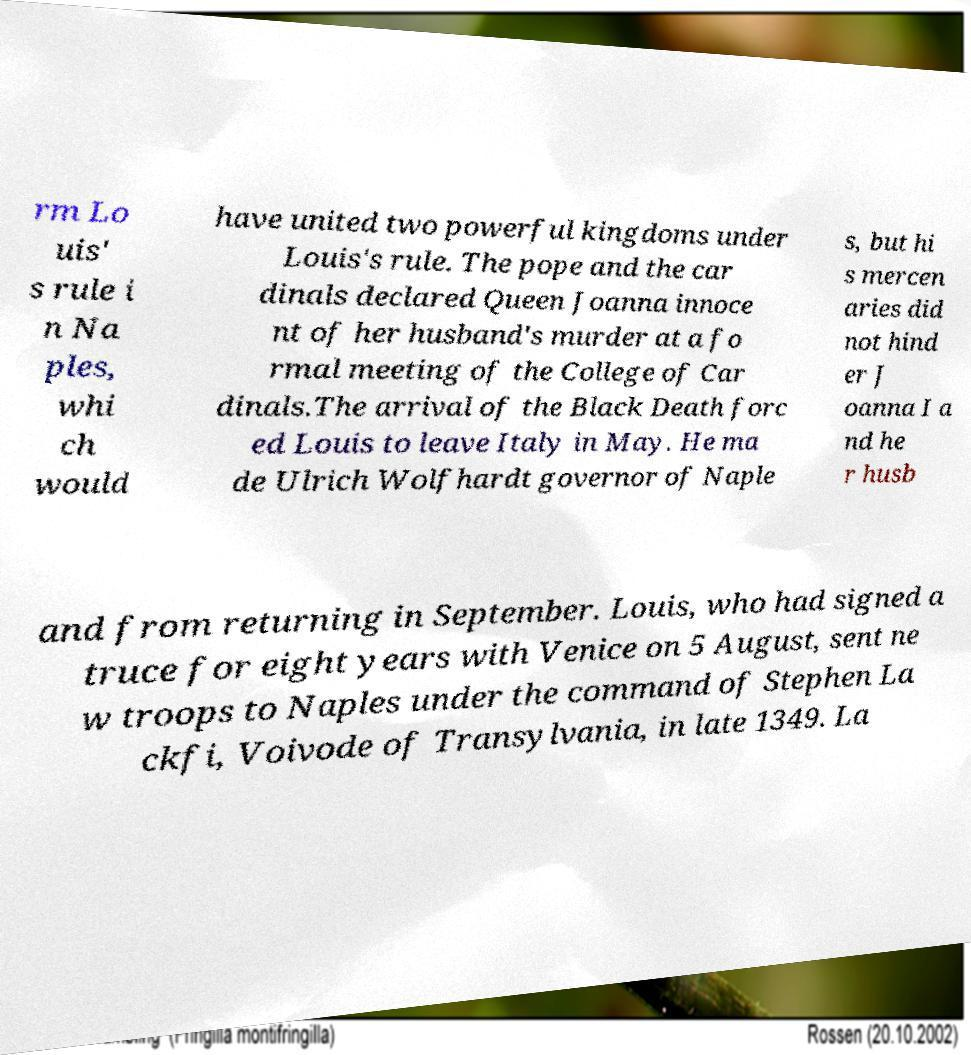Please identify and transcribe the text found in this image. rm Lo uis' s rule i n Na ples, whi ch would have united two powerful kingdoms under Louis's rule. The pope and the car dinals declared Queen Joanna innoce nt of her husband's murder at a fo rmal meeting of the College of Car dinals.The arrival of the Black Death forc ed Louis to leave Italy in May. He ma de Ulrich Wolfhardt governor of Naple s, but hi s mercen aries did not hind er J oanna I a nd he r husb and from returning in September. Louis, who had signed a truce for eight years with Venice on 5 August, sent ne w troops to Naples under the command of Stephen La ckfi, Voivode of Transylvania, in late 1349. La 